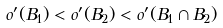<formula> <loc_0><loc_0><loc_500><loc_500>o ^ { \prime } ( B _ { 1 } ) < o ^ { \prime } ( B _ { 2 } ) < o ^ { \prime } ( B _ { 1 } \cap B _ { 2 } )</formula> 